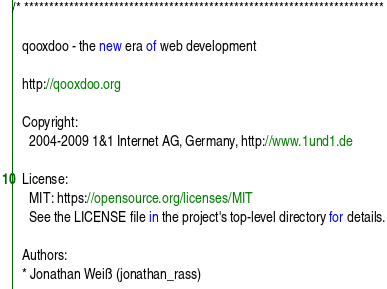<code> <loc_0><loc_0><loc_500><loc_500><_JavaScript_>/* ************************************************************************

   qooxdoo - the new era of web development

   http://qooxdoo.org

   Copyright:
     2004-2009 1&1 Internet AG, Germany, http://www.1und1.de

   License:
     MIT: https://opensource.org/licenses/MIT
     See the LICENSE file in the project's top-level directory for details.

   Authors:
   * Jonathan Weiß (jonathan_rass)</code> 